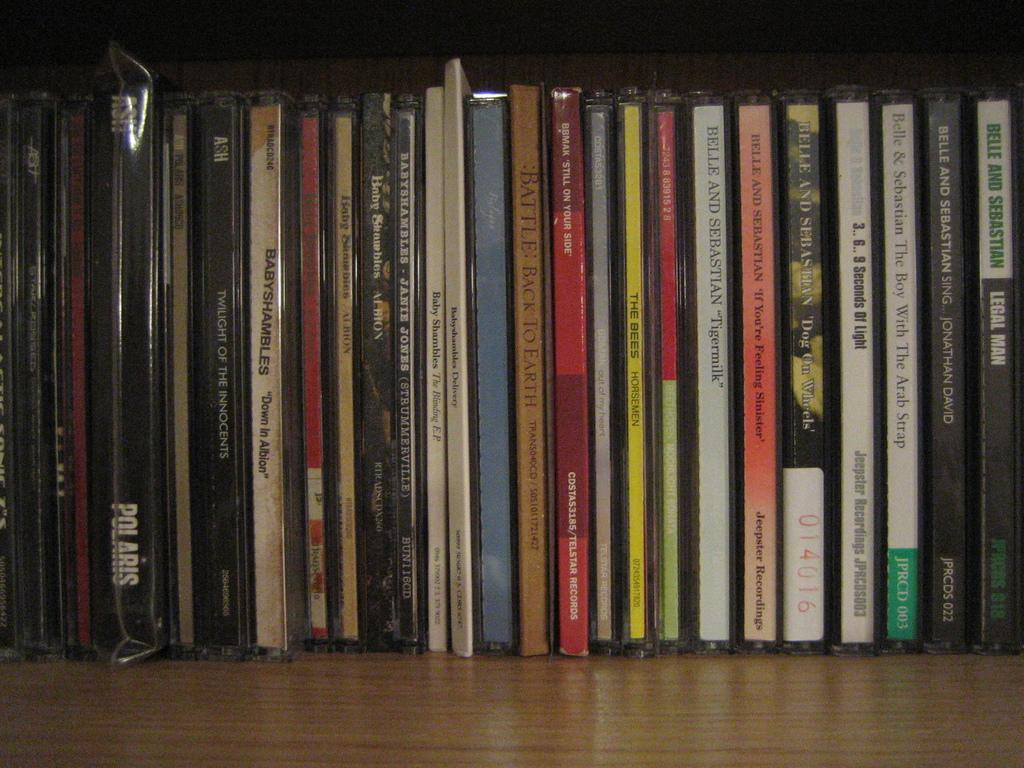<image>
Offer a succinct explanation of the picture presented. A large selection of music CD's, with a bunch by Belle and Sebastian. 